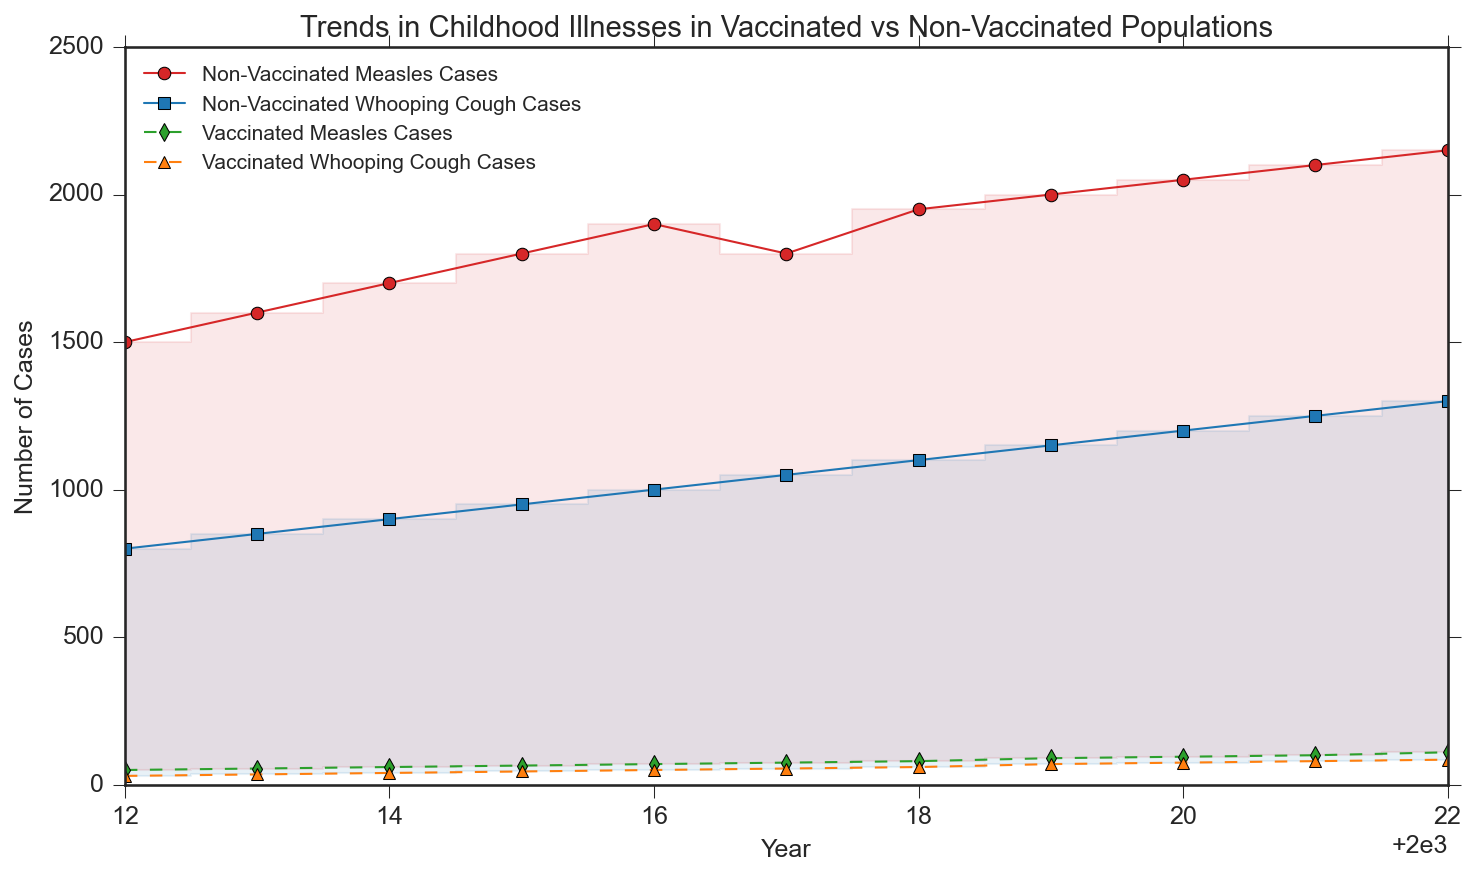How has the number of measles cases changed in the non-vaccinated population over the past decade? By looking at the 'Non-Vaccinated Measles Cases' line (red line), we can see an increase over the years, from 1500 in 2012 to 2150 in 2022.
Answer: Increased from 1500 to 2150 How does the number of measles cases in vaccinated populations compare to non-vaccinated populations in 2022? By comparing the heights of the green line (Vaccinated Measles Cases) and the red line (Non-Vaccinated Measles Cases) in 2022, we see that the non-vaccinated population had 2150 cases while the vaccinated population had 110 cases.
Answer: Non-vaccinated: 2150, Vaccinated: 110 Which disease has the highest number of cases among vaccinated children in any year? By looking at the orange and green lines (Vaccinated Whooping Cough and Vaccinated Measles Cases), the highest number is for vaccinated whooping cough in 2022 with 85 cases.
Answer: Vaccinated whooping cough in 2022 with 85 cases Which year had the highest number of whooping cough cases in the non-vaccinated population? By following the blue line (Non-Vaccinated Whooping Cough Cases) to its peak, we see that 2022 had the highest number of cases with 1300.
Answer: 2022 Are there any years where the number of measles cases in the vaccinated population remained the same? By examining the green line (Vaccinated Measles Cases), there are no flat sections indicating no year where the number remained the same; it increased every year.
Answer: No What is the difference in whooping cough cases between vaccinated and non-vaccinated populations in 2015? By comparing the blue line (Non-Vaccinated) and orange line (Vaccinated) in 2015, there are 950 non-vaccinated cases and 45 vaccinated cases, thus the difference is 950 - 45 = 905.
Answer: 905 In which year did the number of measles cases in the vaccinated population surpass 90? By following the green line upward, the number surpasses 90 in the year 2019.
Answer: 2019 What is the total increase in non-vaccinated whooping cough cases from 2012 to 2022? The number of cases increased from 800 in 2012 to 1300 in 2022. The total increase is 1300 - 800 = 500.
Answer: 500 By how much did the number of measles cases in the vaccinated population increase between 2018 and 2022? The number of cases in 2018 was 80 and in 2022 it was 110. The increase is 110 - 80 = 30.
Answer: 30 What is the general trend of case numbers in non-vaccinated populations for both illnesses over the decade? By observing the red and blue lines, both non-vaccinated measles and whooping cough cases show an increasing trend over the years.
Answer: Increasing trend 